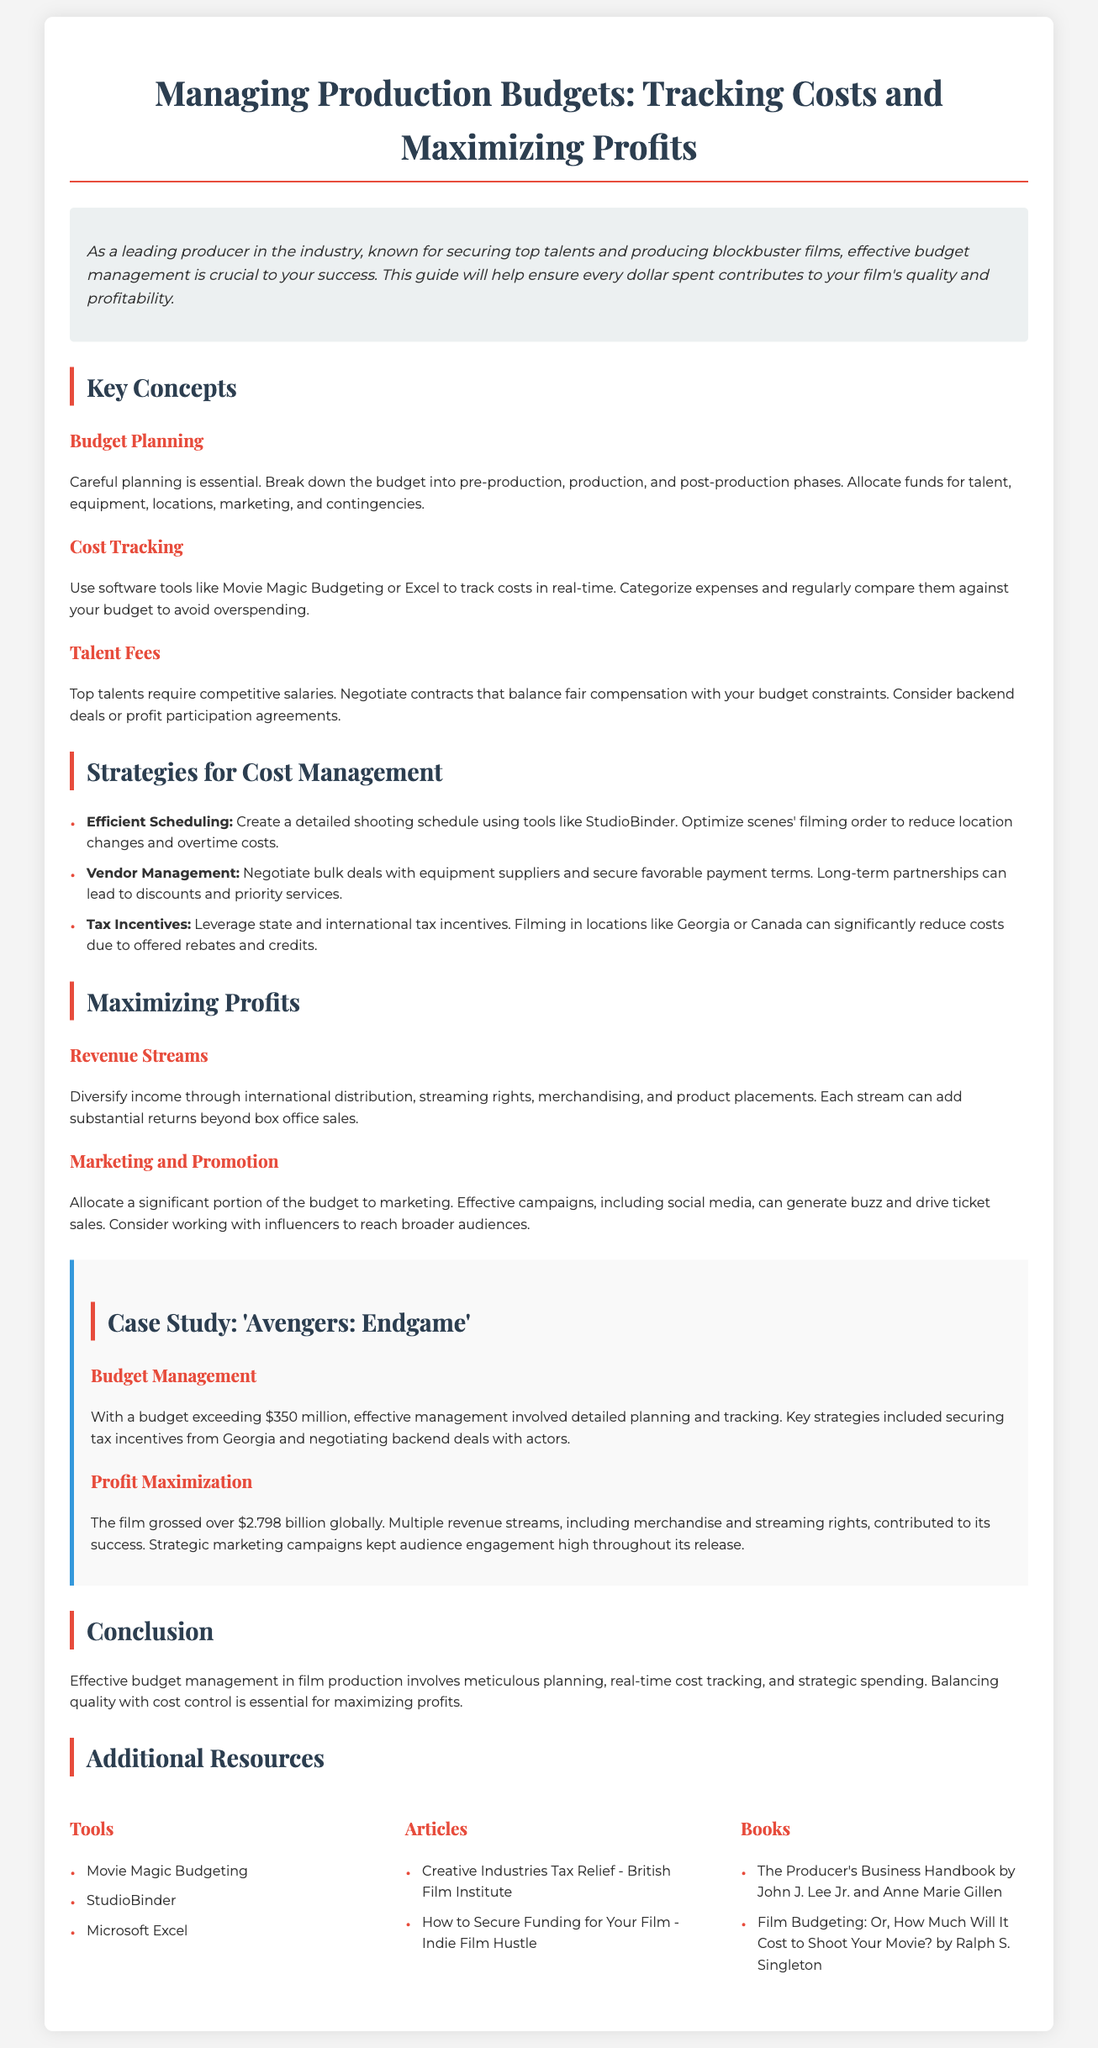what is the title of the guide? The title is prominently displayed at the top of the document.
Answer: Managing Production Budgets: Tracking Costs and Maximizing Profits what percentage of the budget should be allocated to marketing? The document emphasizes the importance of marketing but does not specify a percentage; it indicates to allocate a significant portion.
Answer: significant portion which software tools are suggested for cost tracking? The guide includes specific software recommendations for tracking costs in real-time.
Answer: Movie Magic Budgeting, Excel what was the budget for 'Avengers: Endgame'? The document provides a figure related to the budget used for the case study example.
Answer: exceeding $350 million how much did 'Avengers: Endgame' gross globally? The gross revenue is mentioned in the context of the film's financial success.
Answer: over $2.798 billion what are two strategies for cost management? The guide lists strategies in a bullet format, allowing for easy identification.
Answer: Efficient Scheduling, Vendor Management what type of revenue streams does the guide recommend diversifying into? The document mentions various income sources under the Maximizing Profits section to enhance profitability.
Answer: international distribution, streaming rights, merchandising, product placements which book is suggested for understanding film budgeting? The guide includes specific book recommendations in the Additional Resources section.
Answer: Film Budgeting: Or, How Much Will It Cost to Shoot Your Movie? 